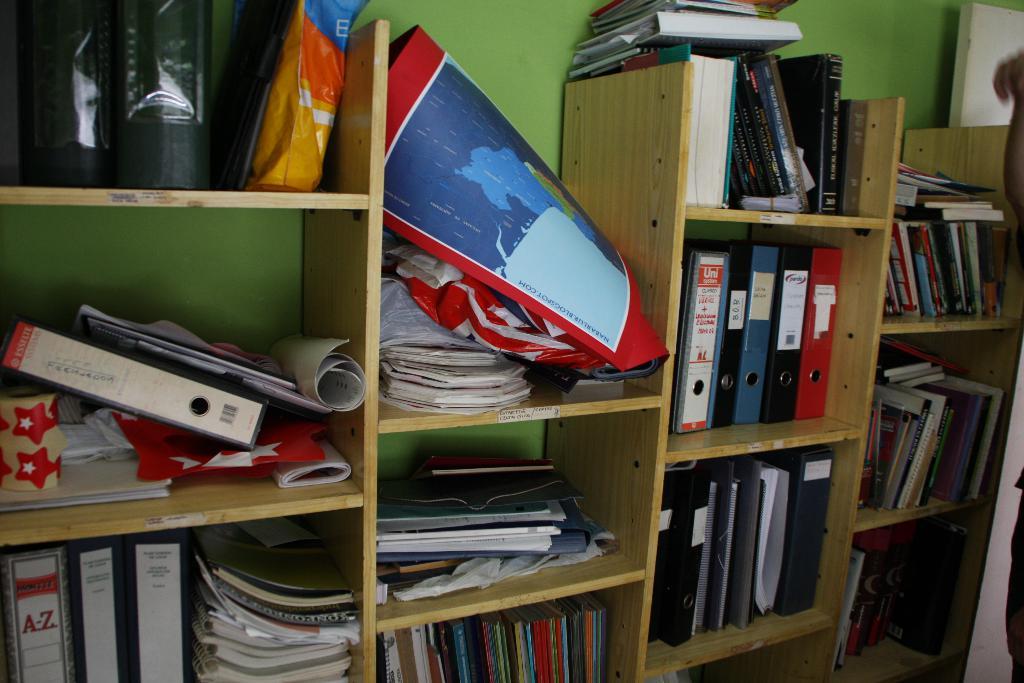What follow the a on the binder on the left bottom shelf?
Offer a terse response. Z. 